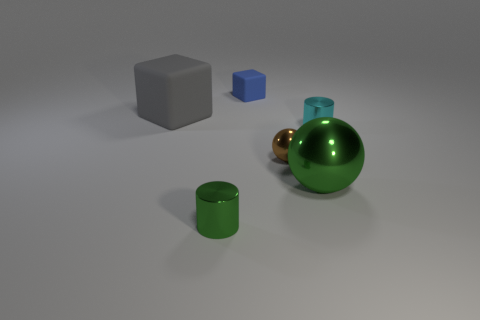Do the brown metal object and the blue matte thing have the same size?
Give a very brief answer. Yes. Are the gray block and the small cylinder that is behind the tiny green shiny cylinder made of the same material?
Ensure brevity in your answer.  No. There is a small metallic cylinder on the left side of the blue matte thing; does it have the same color as the large shiny object?
Provide a short and direct response. Yes. How many small metal things are in front of the tiny cyan object and to the right of the green cylinder?
Provide a short and direct response. 1. How many other objects are there of the same material as the small brown thing?
Provide a short and direct response. 3. Is the small cylinder that is to the left of the brown sphere made of the same material as the small sphere?
Your response must be concise. Yes. How big is the matte thing behind the matte cube on the left side of the cylinder that is on the left side of the cyan metallic cylinder?
Give a very brief answer. Small. What number of other things are there of the same color as the large rubber object?
Give a very brief answer. 0. What shape is the matte object that is the same size as the brown ball?
Make the answer very short. Cube. There is a gray thing that is behind the cyan metallic cylinder; how big is it?
Make the answer very short. Large. 